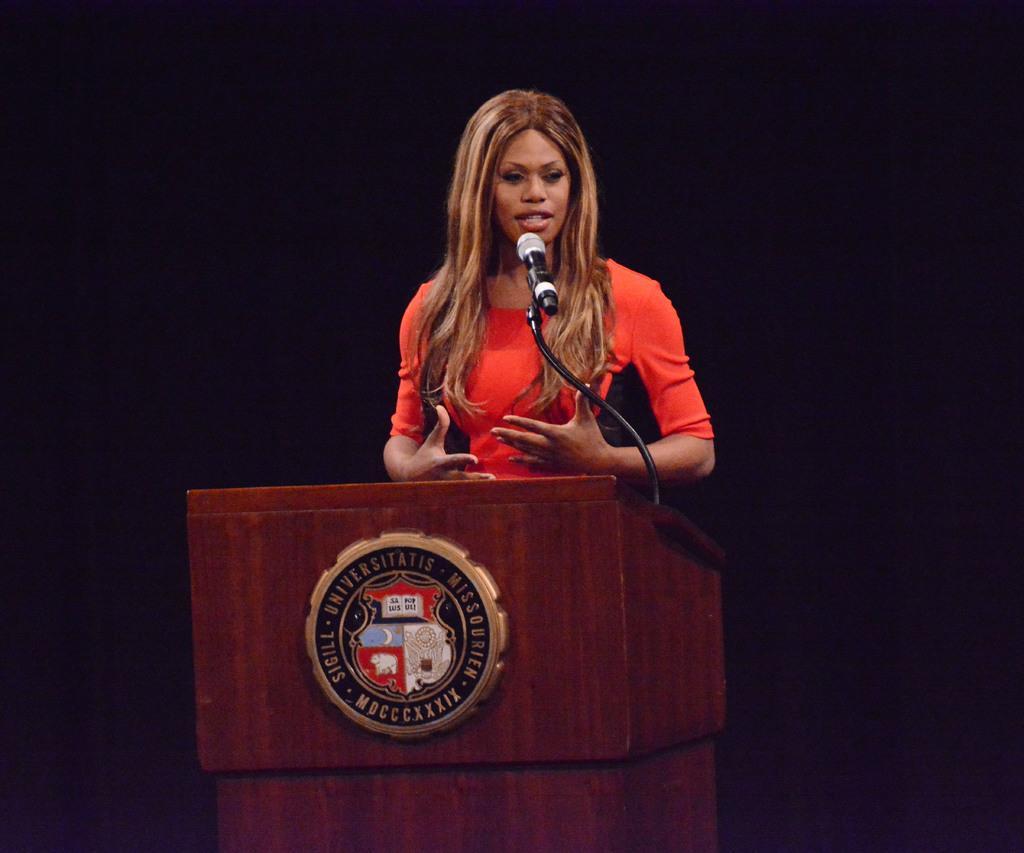In one or two sentences, can you explain what this image depicts? In this image we can see a woman wearing red color dress standing behind wooden podium on which there is some sticker and there is microphone on it and in the background of the image there is black color. 